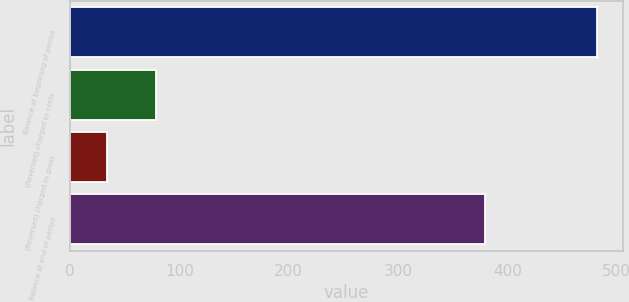Convert chart to OTSL. <chart><loc_0><loc_0><loc_500><loc_500><bar_chart><fcel>Balance at beginning of period<fcel>(Reversed) charged to costs<fcel>(Reversed) charged to gross<fcel>Balance at end of period<nl><fcel>481.6<fcel>78.76<fcel>34<fcel>379.5<nl></chart> 